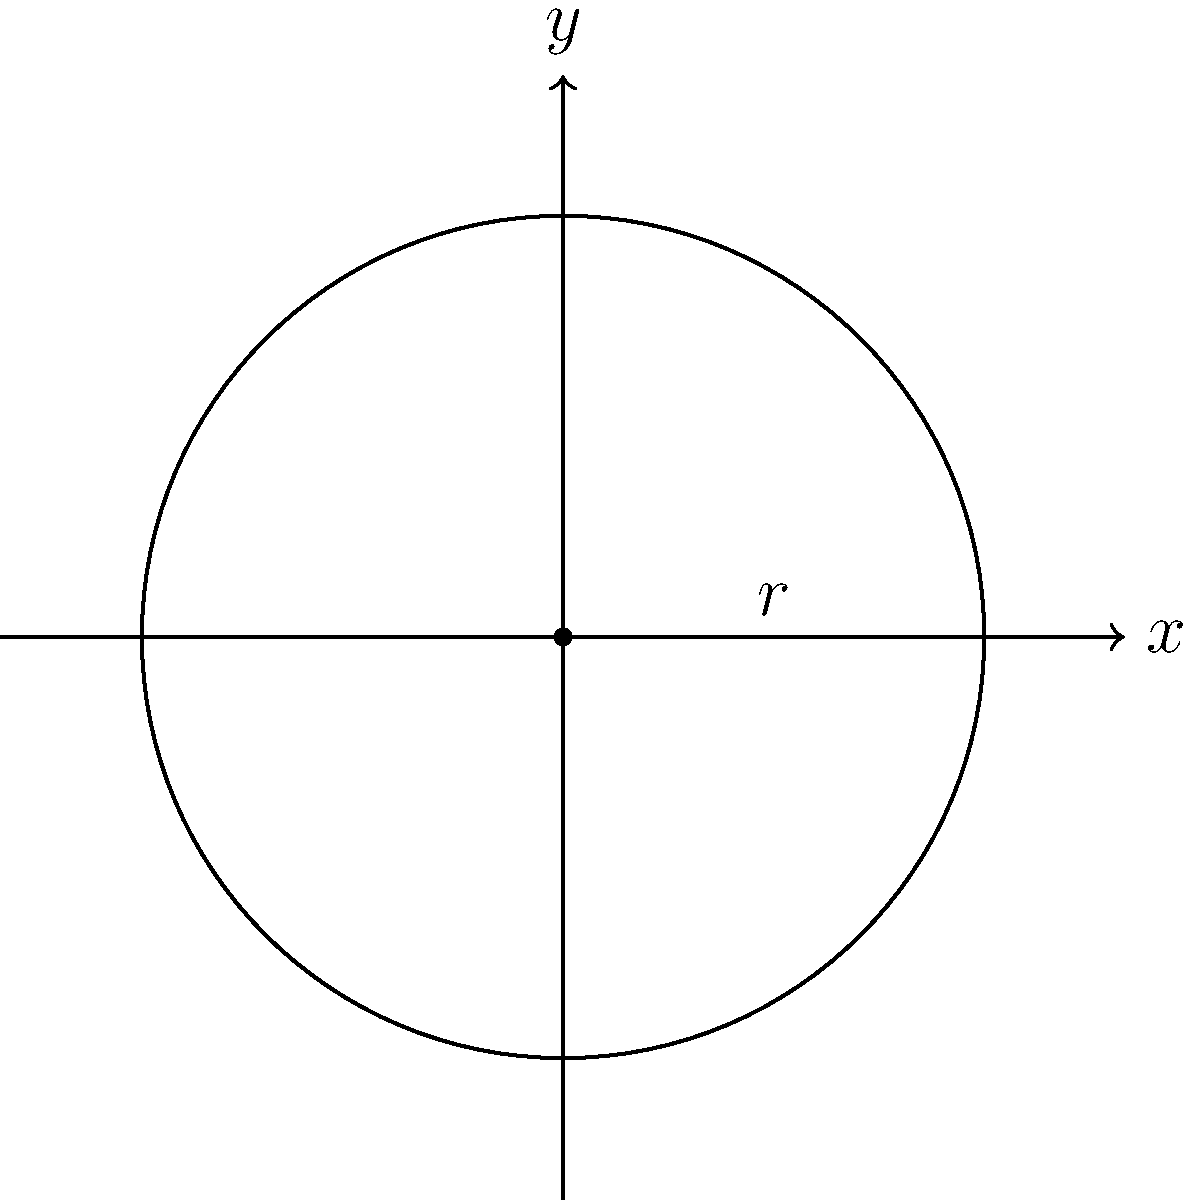A circular public park in Singapore is represented by the equation $x^2 + y^2 = 9$. As part of a urban planning initiative, you need to calculate the area of this park. What is the area of the park in square units? To find the area of the circular park, we need to follow these steps:

1) The general equation of a circle is $(x-h)^2 + (y-k)^2 = r^2$, where $(h,k)$ is the center and $r$ is the radius.

2) In our case, the equation is $x^2 + y^2 = 9$. Comparing this to the general form, we can see that:
   - The center is at (0,0)
   - $r^2 = 9$

3) To find the radius, we take the square root of both sides:
   $r = \sqrt{9} = 3$

4) The formula for the area of a circle is $A = \pi r^2$

5) Substituting our radius:
   $A = \pi (3)^2 = 9\pi$

Therefore, the area of the park is $9\pi$ square units.
Answer: $9\pi$ square units 